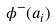Convert formula to latex. <formula><loc_0><loc_0><loc_500><loc_500>\phi ^ { - } ( a _ { i } )</formula> 